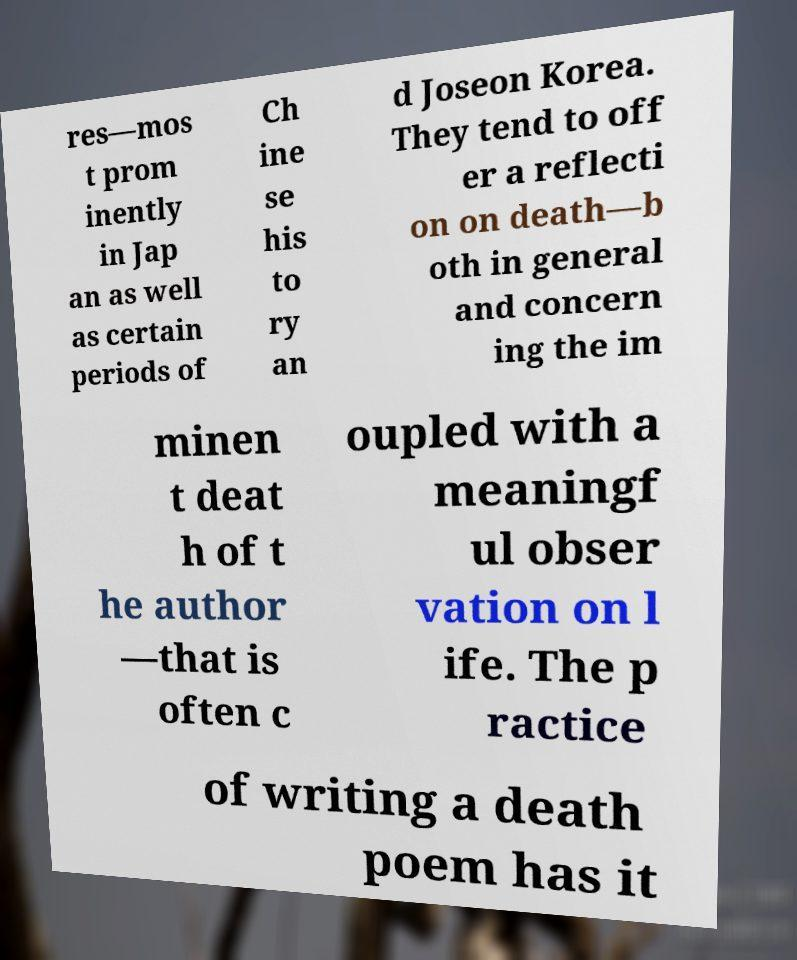I need the written content from this picture converted into text. Can you do that? res—mos t prom inently in Jap an as well as certain periods of Ch ine se his to ry an d Joseon Korea. They tend to off er a reflecti on on death—b oth in general and concern ing the im minen t deat h of t he author —that is often c oupled with a meaningf ul obser vation on l ife. The p ractice of writing a death poem has it 